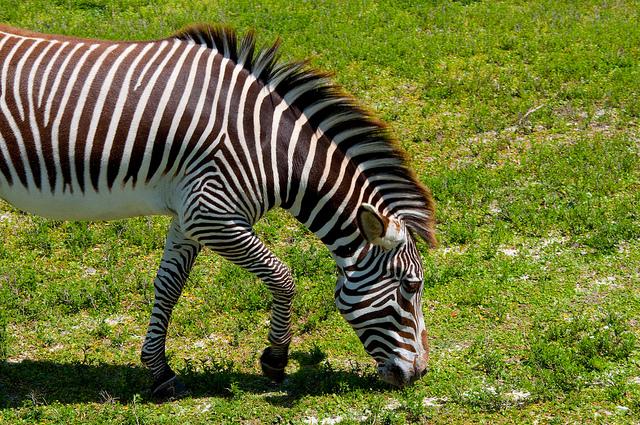Is this a horse?
Answer briefly. No. What is the animal eating?
Quick response, please. Grass. How old is animal?
Be succinct. 10 years. 